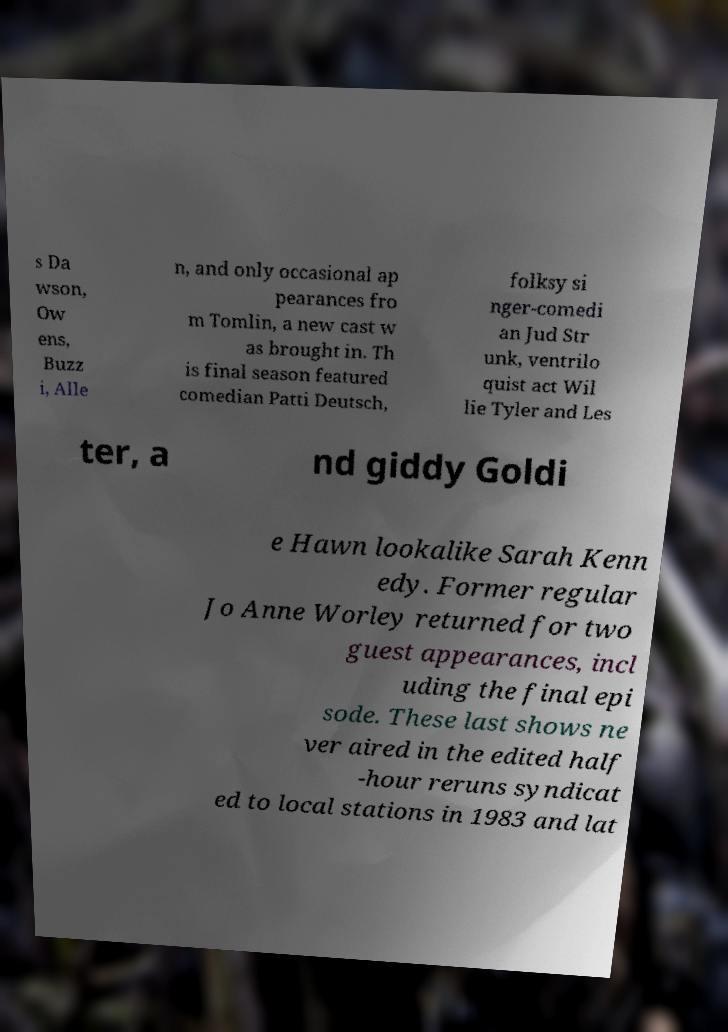Can you accurately transcribe the text from the provided image for me? s Da wson, Ow ens, Buzz i, Alle n, and only occasional ap pearances fro m Tomlin, a new cast w as brought in. Th is final season featured comedian Patti Deutsch, folksy si nger-comedi an Jud Str unk, ventrilo quist act Wil lie Tyler and Les ter, a nd giddy Goldi e Hawn lookalike Sarah Kenn edy. Former regular Jo Anne Worley returned for two guest appearances, incl uding the final epi sode. These last shows ne ver aired in the edited half -hour reruns syndicat ed to local stations in 1983 and lat 